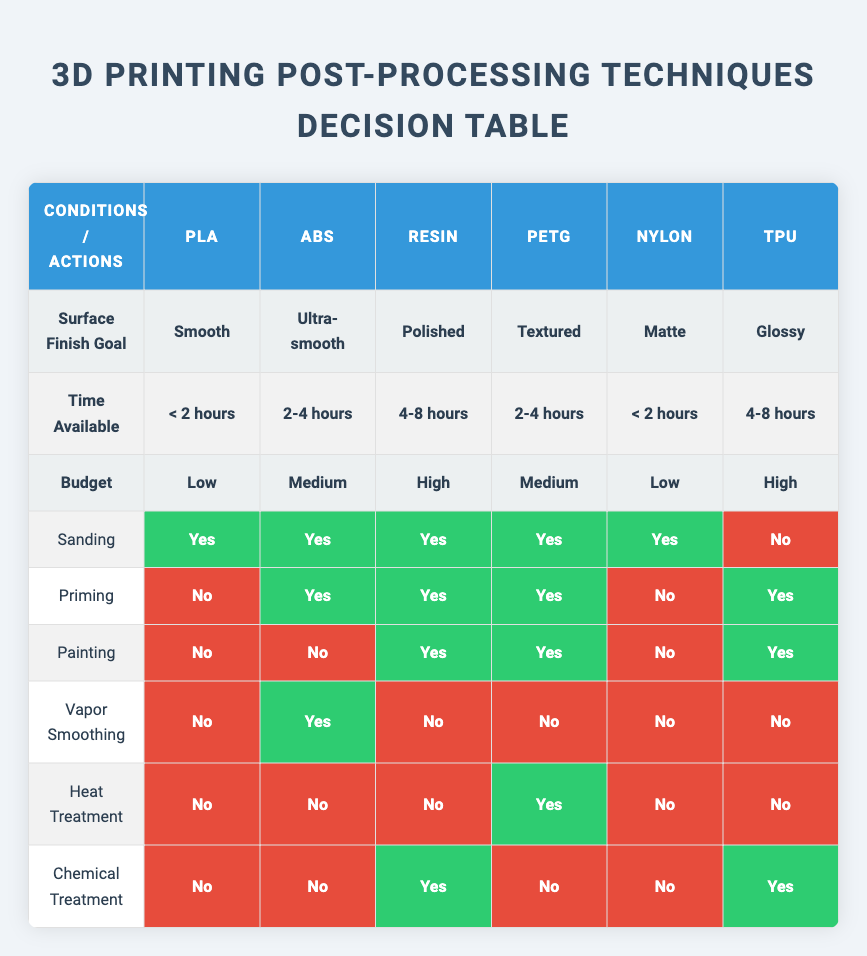What are the surface finish goals for PLA material? By looking at the table, I locate the column for PLA, which shows the surface finish goal listed as "Smooth."
Answer: Smooth Which materials can be primed according to the table? I review each material's row and note whether "Priming" is marked as "Yes." It is marked as "Yes" for ABS, Resin, PETG, and TPU.
Answer: ABS, Resin, PETG, TPU Is vapor smoothing an option for Nylon? I check the Nylon row under the "Vapor Smoothing" column, which indicates "No." Thus, vapor smoothing is not an option for Nylon.
Answer: No How many materials can achieve a textured finish within 2-4 hours? I see that PETG is the only material listed with a surface finish goal of "Textured" and it indicates that it requires 2-4 hours. Therefore, there is only one material.
Answer: 1 Which of the materials can be chemically treated? I investigate the "Chemical Treatment" column and find that it is marked "Yes" for Resin and TPU, allowing those materials to be chemically treated.
Answer: Resin, TPU What is the budget requirement for achieving an ultra-smooth finish? I check the "ABS" row and find that the corresponding budget requirement for achieving an ultra-smooth finish is "Medium."
Answer: Medium Which material has the longest time available for finishing and what is the action allowed? I look for the row with the maximum time available which is 4-8 hours, identifying the materials as Resin and TPU. For Resin, the actions listed are sanding, priming, painting, and chemical treatment; for TPU, they are priming, painting, and chemical treatment. Thus, the actions allowed for the one with the longest time available (4-8 hours) are sanding, priming, painting, and chemical treatment for Resin.
Answer: Sanding, Priming, Painting, Chemical Treatment (for Resin) Can sanding be performed on TPU material for finishing? In the TPU row, the "Sanding" action is marked as "No," indicating that sanding cannot be performed on TPU for finishing.
Answer: No Which post-processing techniques can be used for a high-budget material? I scan the "High" budget materials, which are Resin and TPU. For these, the allowed techniques are: for Resin - sanding, priming, painting, and chemical treatment; for TPU - priming, painting, and chemical treatment.
Answer: Sanding, Priming, Painting, Chemical Treatment (for Resin); Priming, Painting, Chemical Treatment (for TPU) 